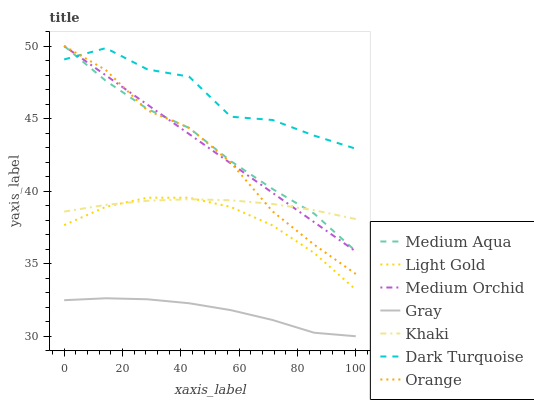Does Gray have the minimum area under the curve?
Answer yes or no. Yes. Does Dark Turquoise have the maximum area under the curve?
Answer yes or no. Yes. Does Khaki have the minimum area under the curve?
Answer yes or no. No. Does Khaki have the maximum area under the curve?
Answer yes or no. No. Is Medium Orchid the smoothest?
Answer yes or no. Yes. Is Dark Turquoise the roughest?
Answer yes or no. Yes. Is Khaki the smoothest?
Answer yes or no. No. Is Khaki the roughest?
Answer yes or no. No. Does Gray have the lowest value?
Answer yes or no. Yes. Does Khaki have the lowest value?
Answer yes or no. No. Does Orange have the highest value?
Answer yes or no. Yes. Does Khaki have the highest value?
Answer yes or no. No. Is Gray less than Medium Aqua?
Answer yes or no. Yes. Is Dark Turquoise greater than Gray?
Answer yes or no. Yes. Does Orange intersect Medium Orchid?
Answer yes or no. Yes. Is Orange less than Medium Orchid?
Answer yes or no. No. Is Orange greater than Medium Orchid?
Answer yes or no. No. Does Gray intersect Medium Aqua?
Answer yes or no. No. 